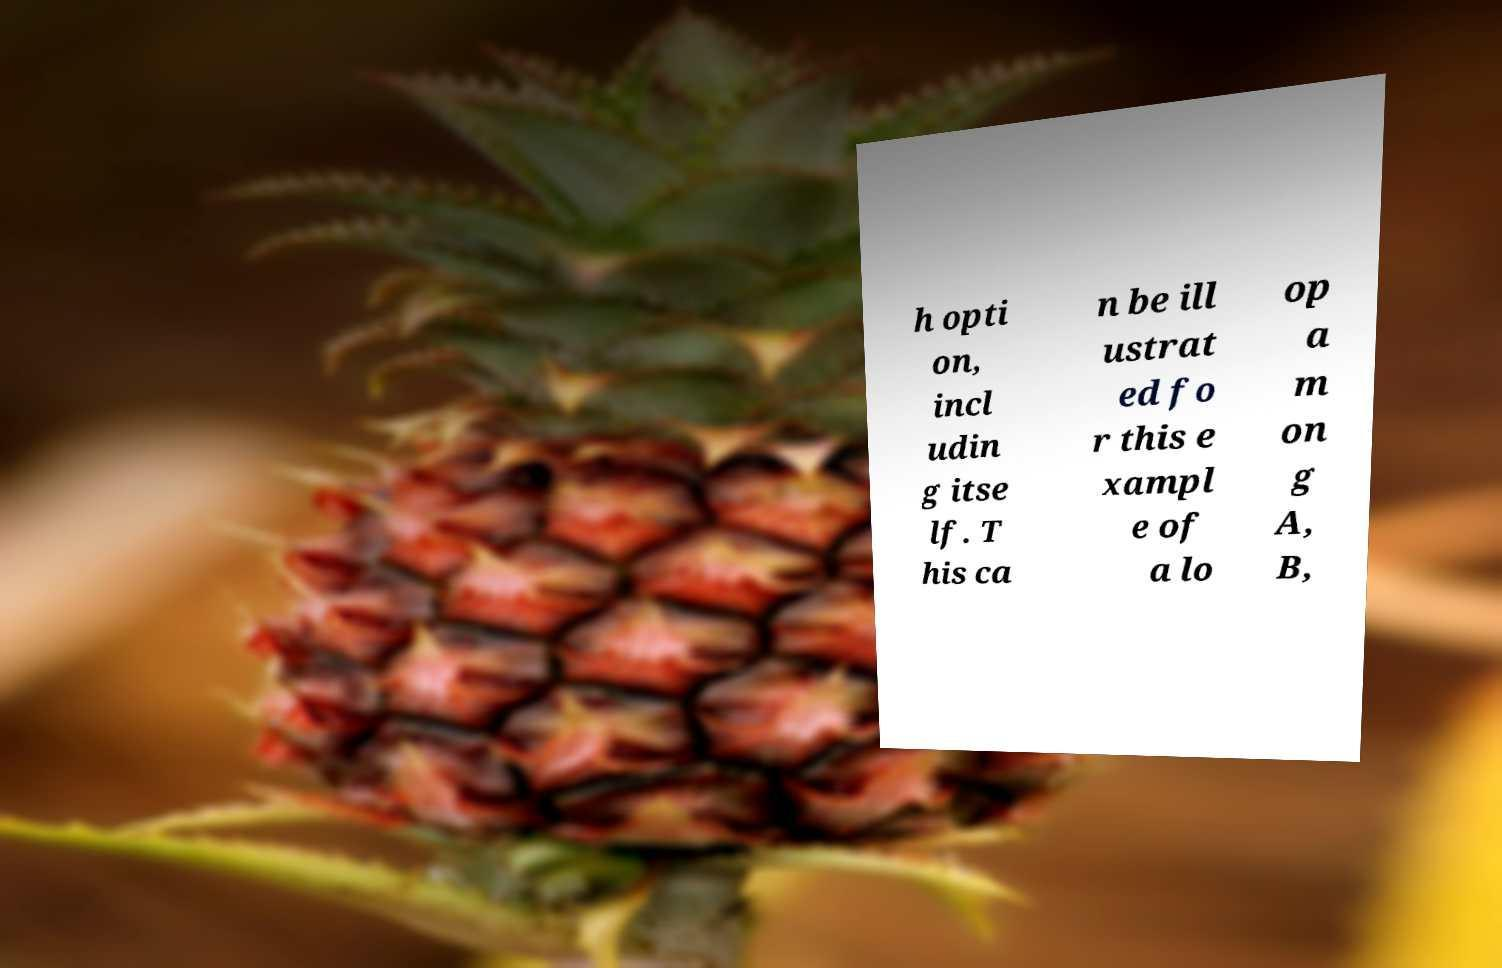Could you assist in decoding the text presented in this image and type it out clearly? h opti on, incl udin g itse lf. T his ca n be ill ustrat ed fo r this e xampl e of a lo op a m on g A, B, 